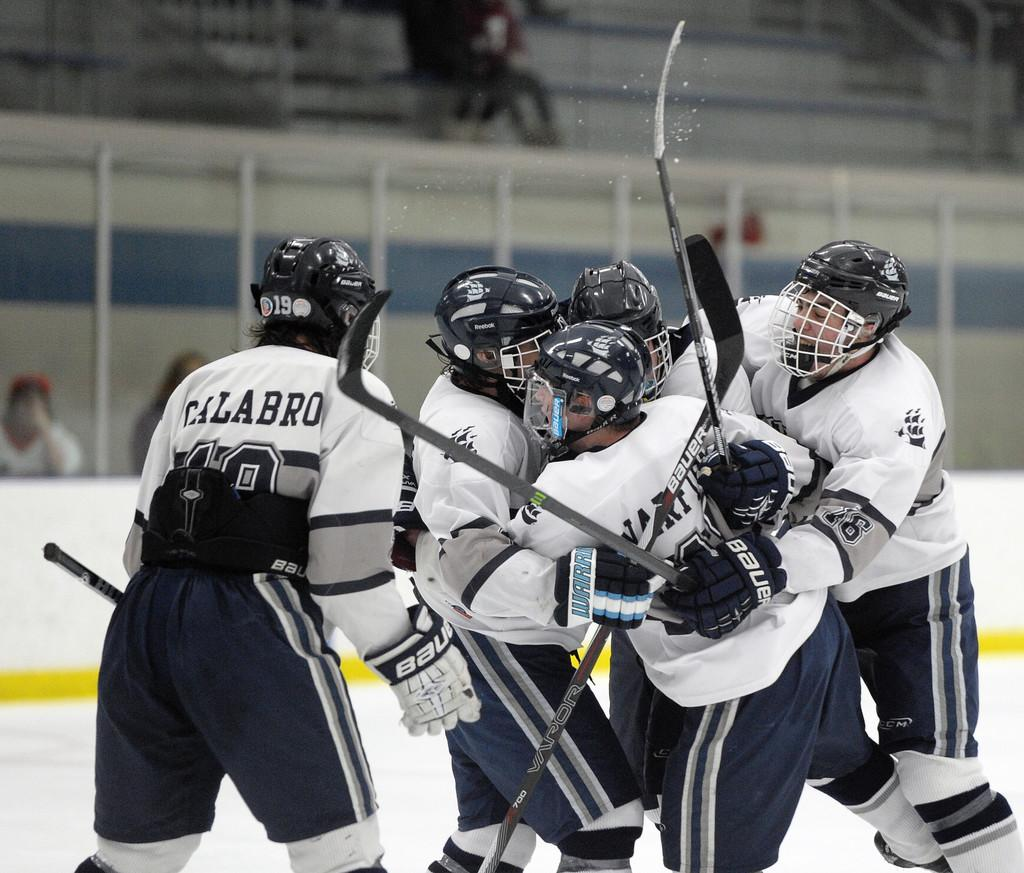What are the persons in the image doing? The persons in the image are standing and holding bats in their hands. What protective gear are the persons wearing? The persons are wearing helmets on their heads. What else can be seen in the background of the image? There are other persons and objects visible in the background of the image. What type of stew is being prepared by the persons in the image? There is no indication of any stew being prepared in the image; the persons are holding bats and wearing helmets. Can you tell me which elbow is more prominent in the image? There is no specific elbow visible in the image, as the focus is on the persons holding bats and wearing helmets. 